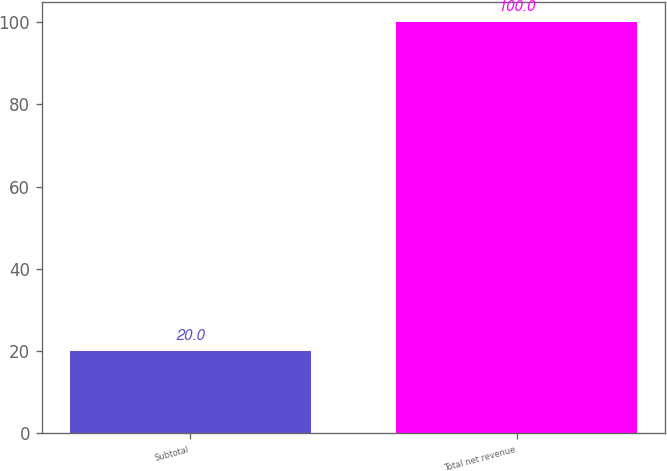Convert chart. <chart><loc_0><loc_0><loc_500><loc_500><bar_chart><fcel>Subtotal<fcel>Total net revenue<nl><fcel>20<fcel>100<nl></chart> 